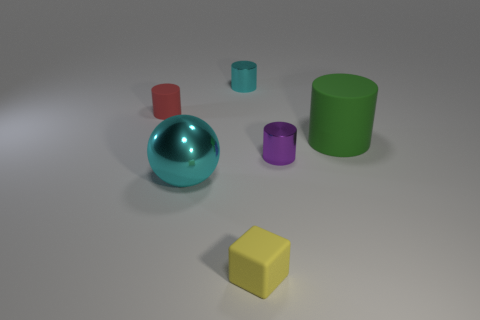There is a purple metal thing; is its size the same as the cyan object in front of the small red rubber cylinder?
Ensure brevity in your answer.  No. What number of other things are there of the same size as the ball?
Offer a terse response. 1. How many other things are the same color as the tiny block?
Provide a succinct answer. 0. What number of other things are the same shape as the yellow rubber thing?
Your answer should be very brief. 0. Does the red rubber cylinder have the same size as the ball?
Make the answer very short. No. Are there any small shiny cylinders?
Give a very brief answer. Yes. Is there any other thing that has the same material as the purple thing?
Provide a short and direct response. Yes. Is there a green ball made of the same material as the small red object?
Your answer should be compact. No. What is the material of the cyan thing that is the same size as the green object?
Provide a succinct answer. Metal. How many other yellow matte objects are the same shape as the tiny yellow rubber object?
Your response must be concise. 0. 